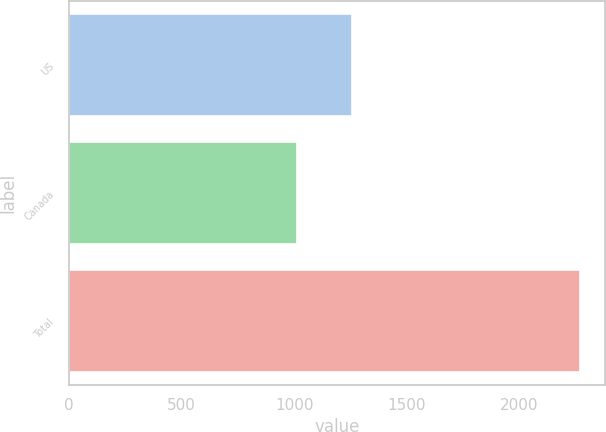Convert chart to OTSL. <chart><loc_0><loc_0><loc_500><loc_500><bar_chart><fcel>US<fcel>Canada<fcel>Total<nl><fcel>1257<fcel>1011<fcel>2268<nl></chart> 